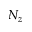Convert formula to latex. <formula><loc_0><loc_0><loc_500><loc_500>N _ { z }</formula> 